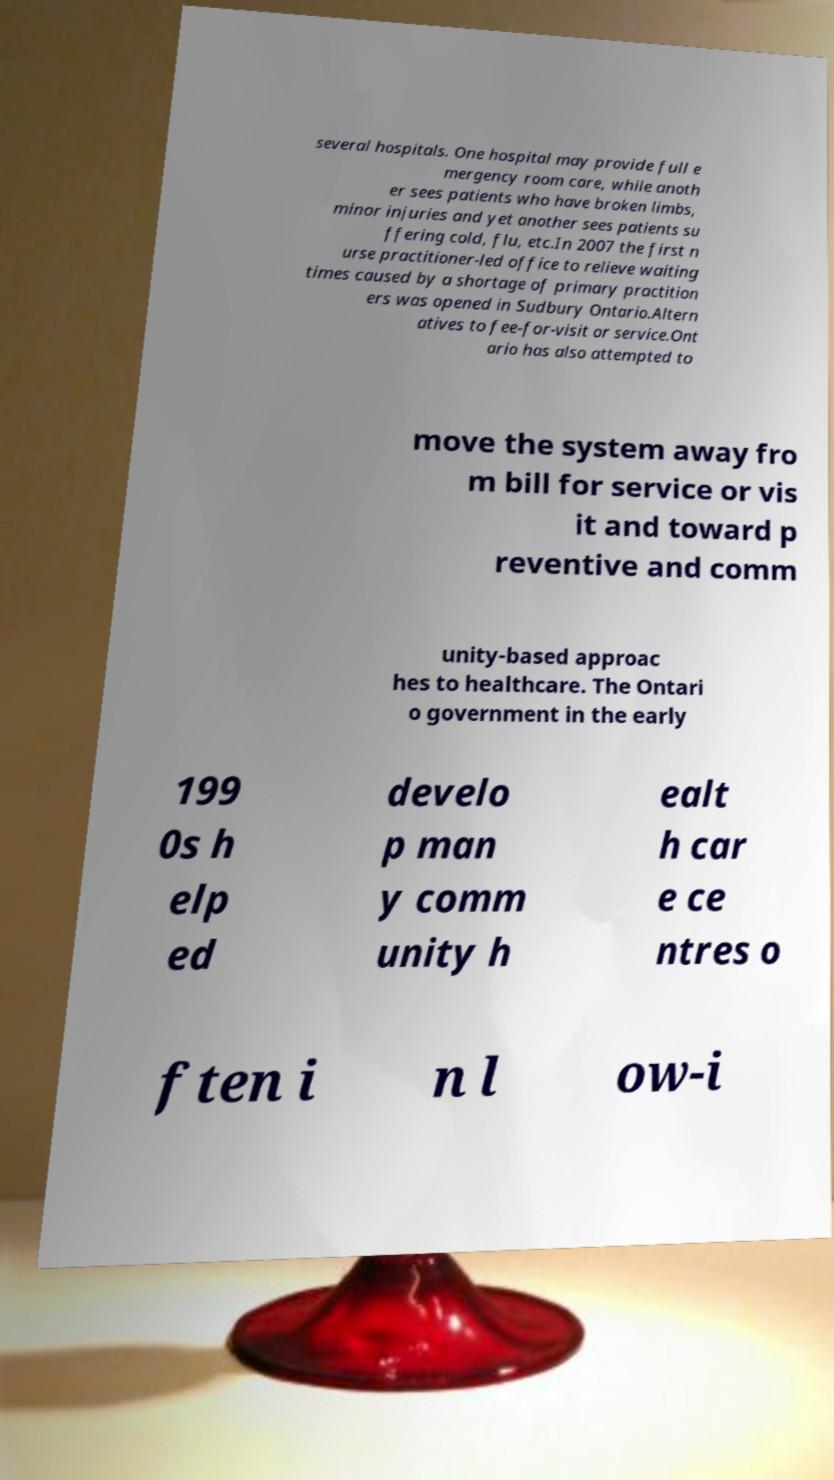For documentation purposes, I need the text within this image transcribed. Could you provide that? several hospitals. One hospital may provide full e mergency room care, while anoth er sees patients who have broken limbs, minor injuries and yet another sees patients su ffering cold, flu, etc.In 2007 the first n urse practitioner-led office to relieve waiting times caused by a shortage of primary practition ers was opened in Sudbury Ontario.Altern atives to fee-for-visit or service.Ont ario has also attempted to move the system away fro m bill for service or vis it and toward p reventive and comm unity-based approac hes to healthcare. The Ontari o government in the early 199 0s h elp ed develo p man y comm unity h ealt h car e ce ntres o ften i n l ow-i 